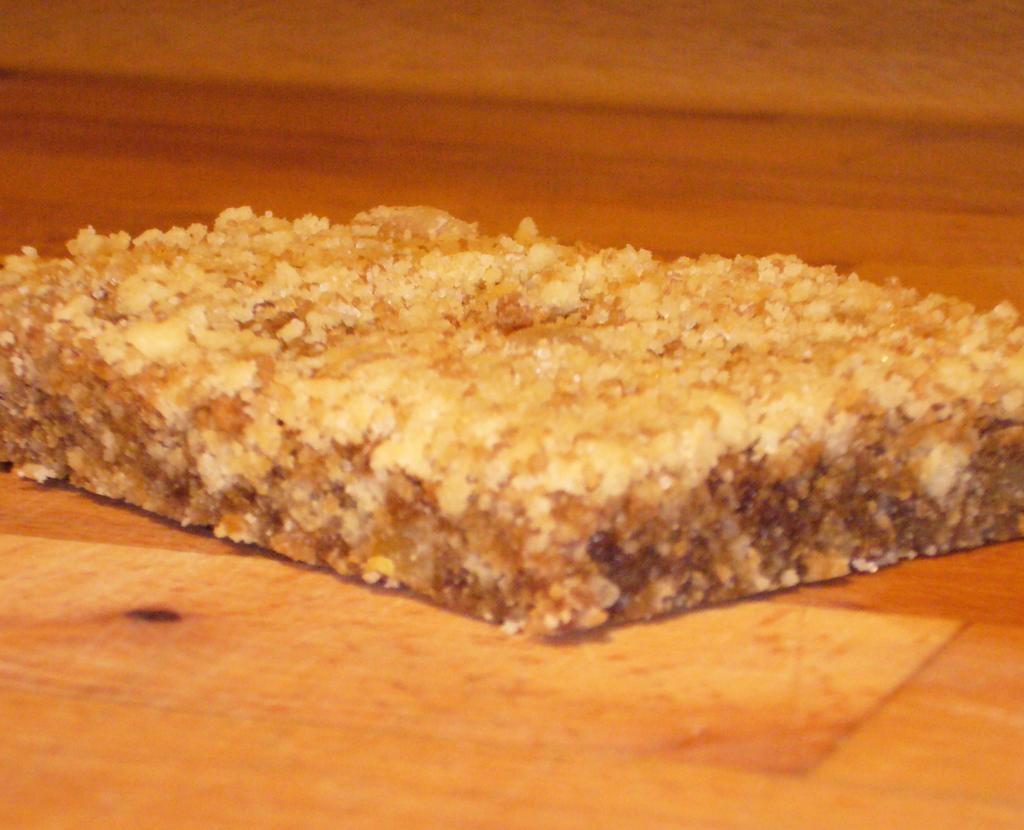Describe this image in one or two sentences. In this image I can see the food item on the brown color surface. I can see the food item is in cream and brown color. 